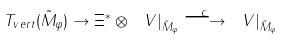Convert formula to latex. <formula><loc_0><loc_0><loc_500><loc_500>T _ { v e r t } ( \tilde { M } _ { \varphi } ) \to \Xi ^ { * } \otimes \ V | _ { { \tilde { M } _ { \varphi } } } \stackrel { c } { \longrightarrow } \ V | _ { \tilde { M } _ { \varphi } }</formula> 